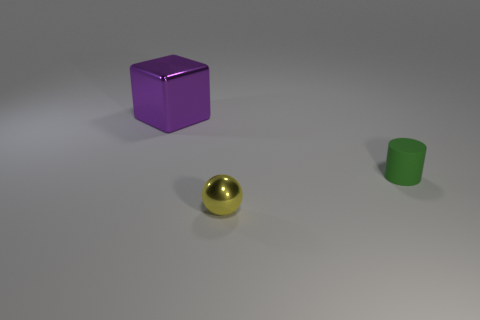Add 3 small shiny spheres. How many objects exist? 6 Subtract 1 balls. How many balls are left? 0 Subtract all cylinders. How many objects are left? 2 Add 3 purple metallic cubes. How many purple metallic cubes exist? 4 Subtract 0 green blocks. How many objects are left? 3 Subtract all brown cylinders. Subtract all yellow spheres. How many cylinders are left? 1 Subtract all big red rubber cylinders. Subtract all small cylinders. How many objects are left? 2 Add 2 metallic blocks. How many metallic blocks are left? 3 